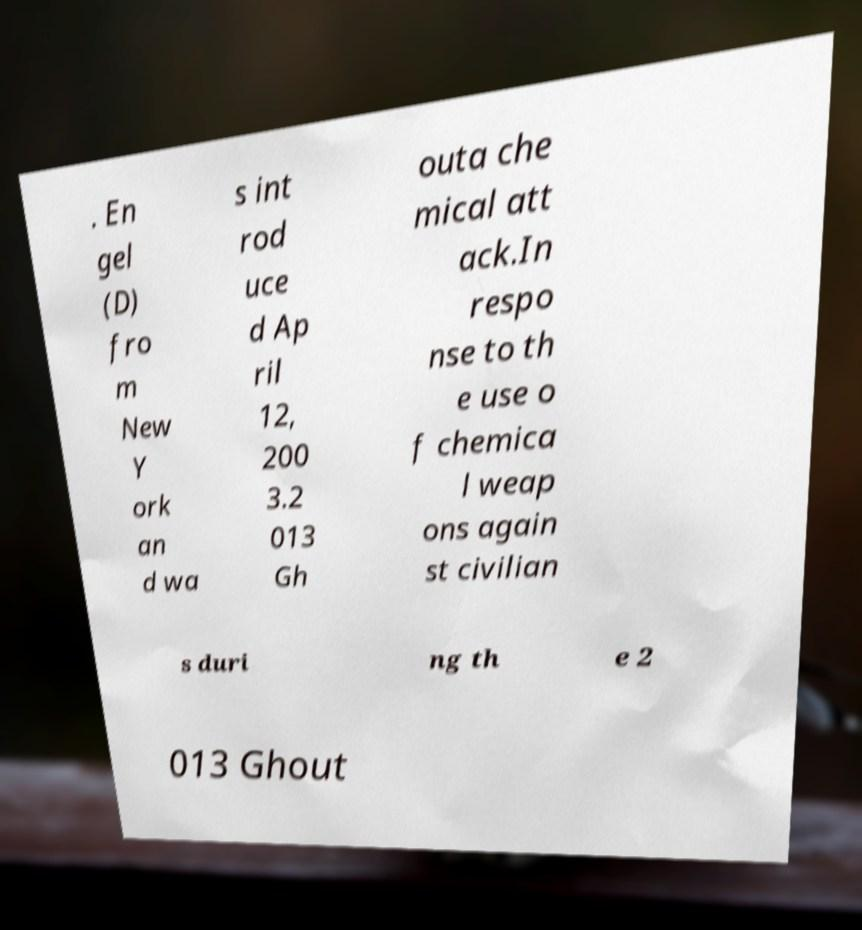Please identify and transcribe the text found in this image. . En gel (D) fro m New Y ork an d wa s int rod uce d Ap ril 12, 200 3.2 013 Gh outa che mical att ack.In respo nse to th e use o f chemica l weap ons again st civilian s duri ng th e 2 013 Ghout 